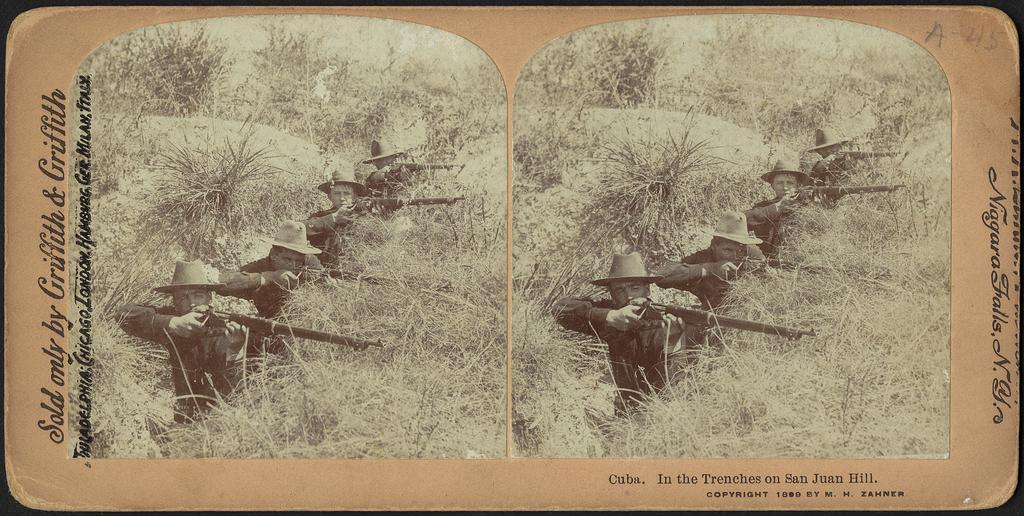In one or two sentences, can you explain what this image depicts? I can see this is a picture of two images sticked to a piece of paper. There are soldiers holding guns in their hands. Also there is grass and plants and some text written on the images. 